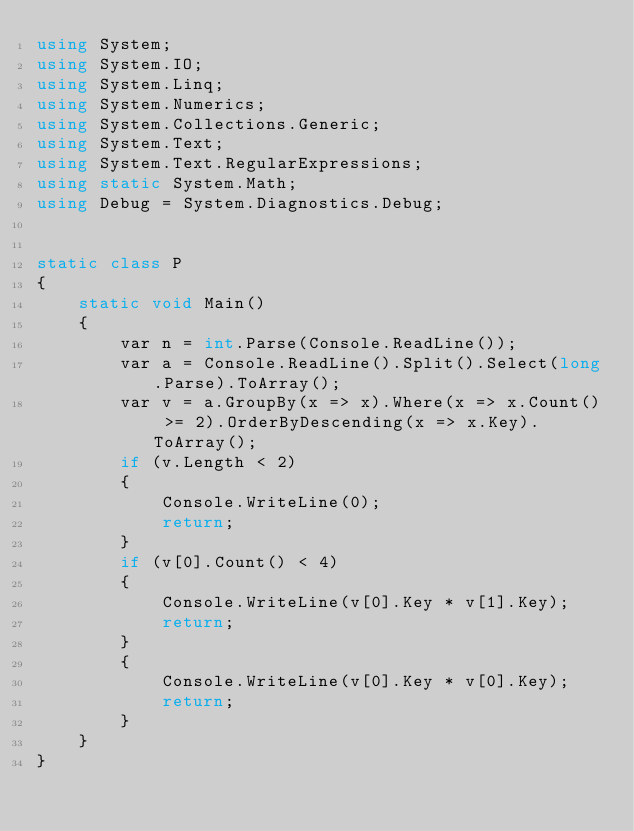Convert code to text. <code><loc_0><loc_0><loc_500><loc_500><_C#_>using System;
using System.IO;
using System.Linq;
using System.Numerics;
using System.Collections.Generic;
using System.Text;
using System.Text.RegularExpressions;
using static System.Math;
using Debug = System.Diagnostics.Debug;


static class P
{
    static void Main()
    {
        var n = int.Parse(Console.ReadLine());
        var a = Console.ReadLine().Split().Select(long.Parse).ToArray();
        var v = a.GroupBy(x => x).Where(x => x.Count() >= 2).OrderByDescending(x => x.Key).ToArray();
        if (v.Length < 2)
        {
            Console.WriteLine(0);
            return;
        }
        if (v[0].Count() < 4)
        {
            Console.WriteLine(v[0].Key * v[1].Key);
            return;
        }
        {
            Console.WriteLine(v[0].Key * v[0].Key);
            return;
        }
    }
}</code> 